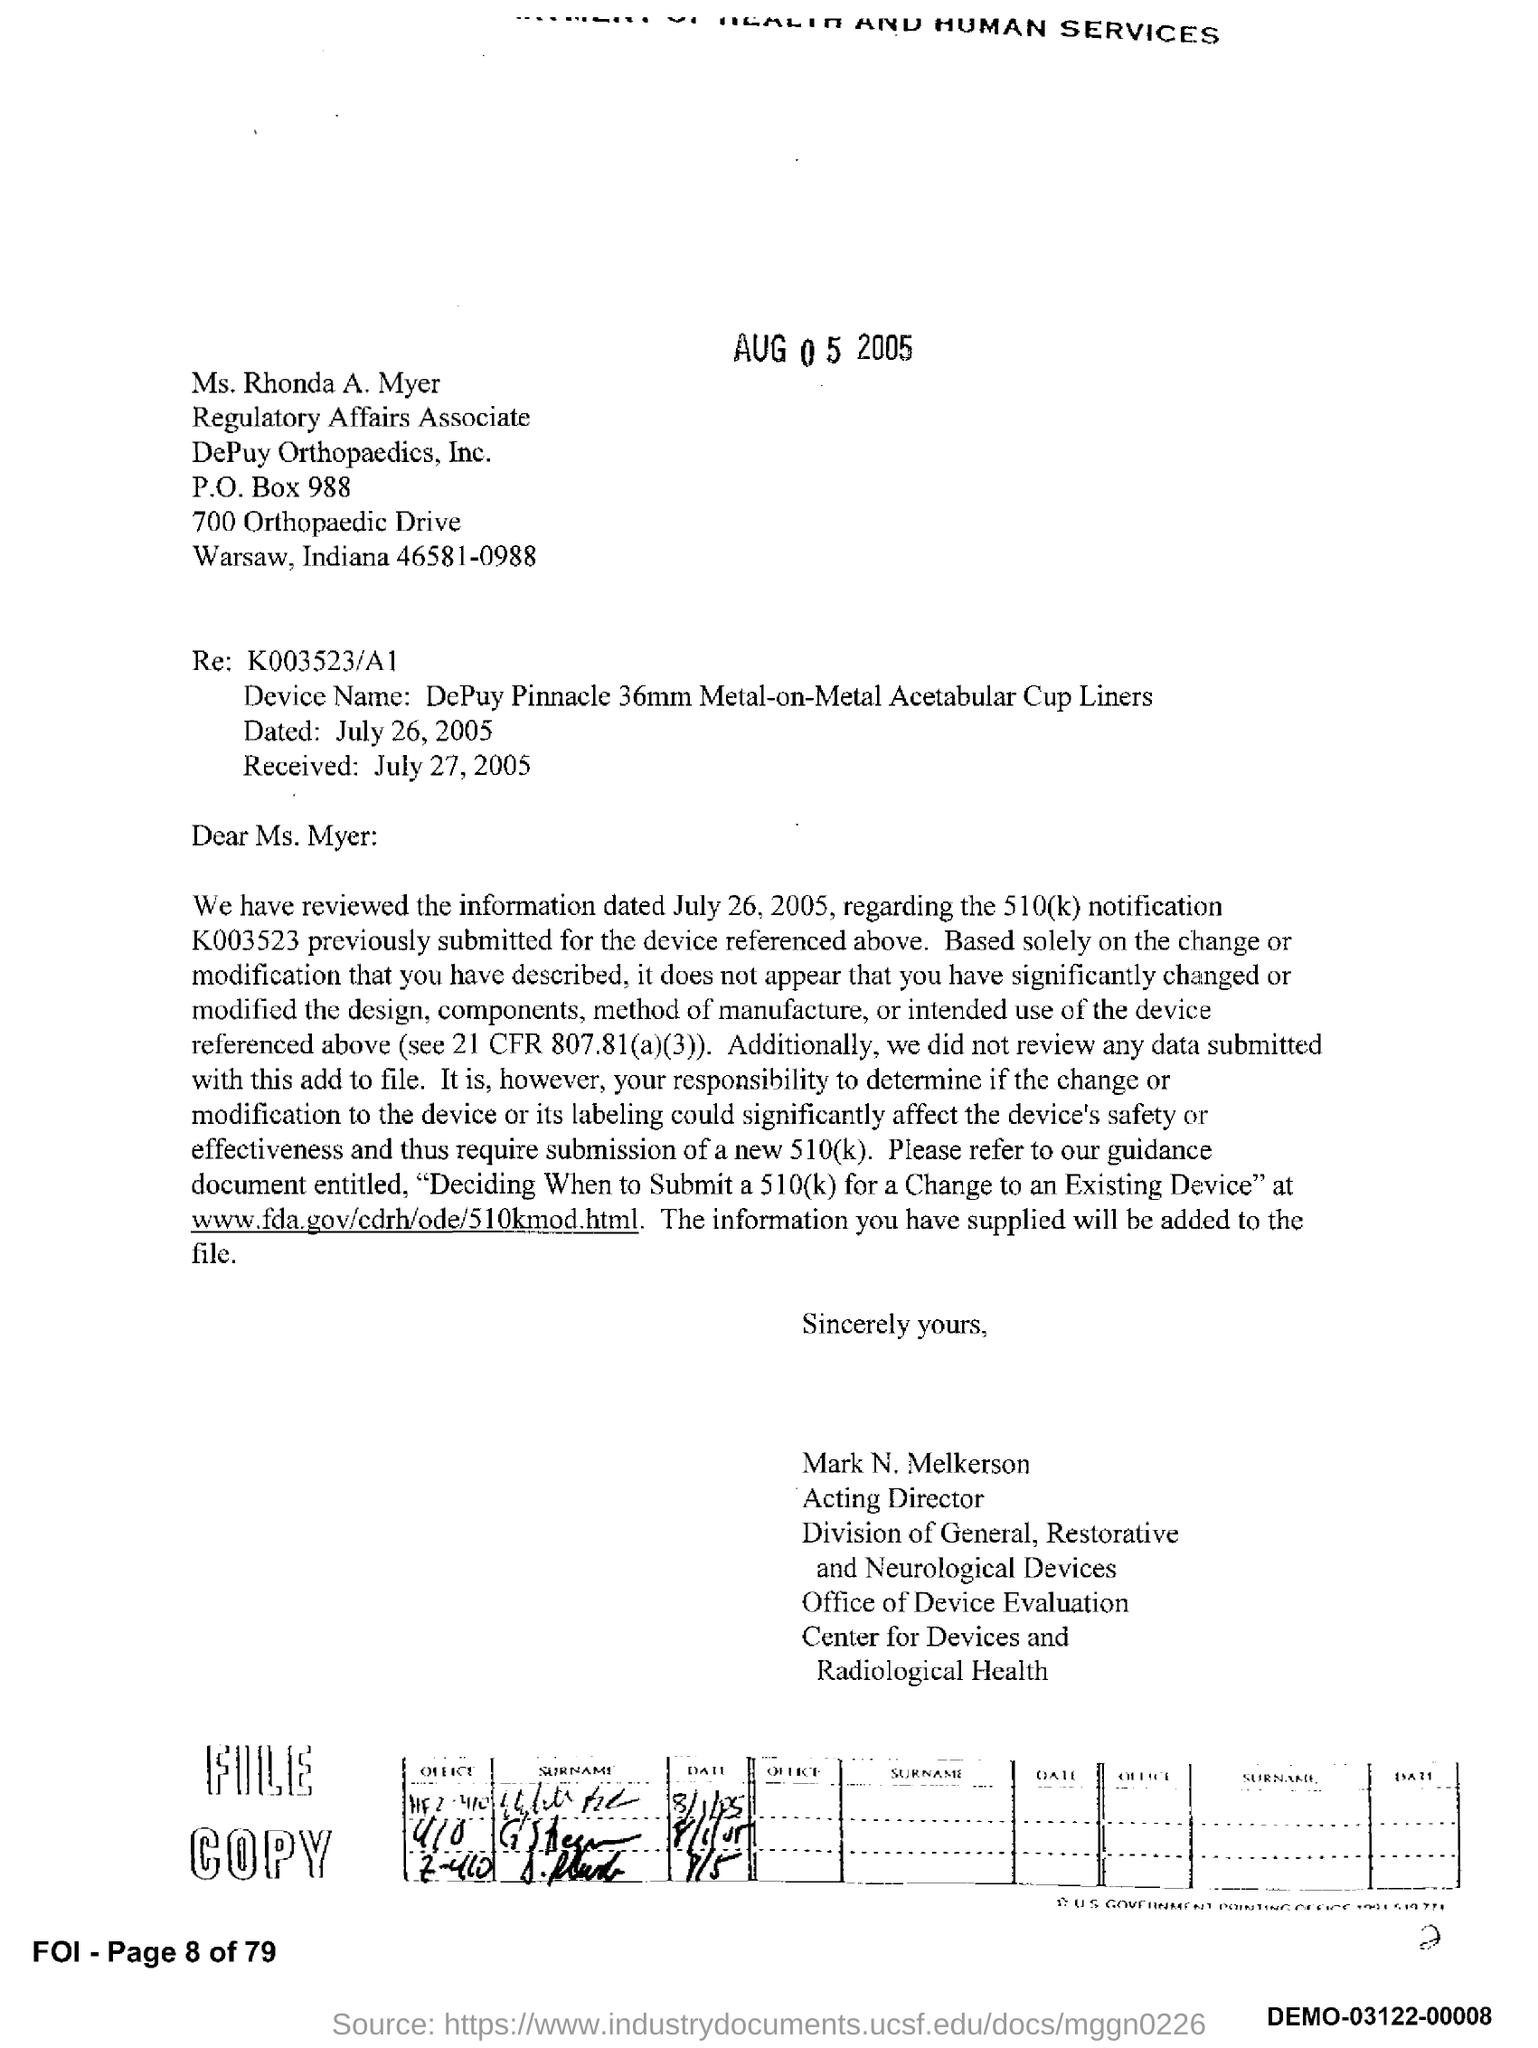What is the PO Box Number mentioned in the document?
Keep it short and to the point. 988. What is the name of the device?
Your answer should be compact. DePuy Pinnacle 36mm Metal-on-Metal Acetabular Cup Liners. 